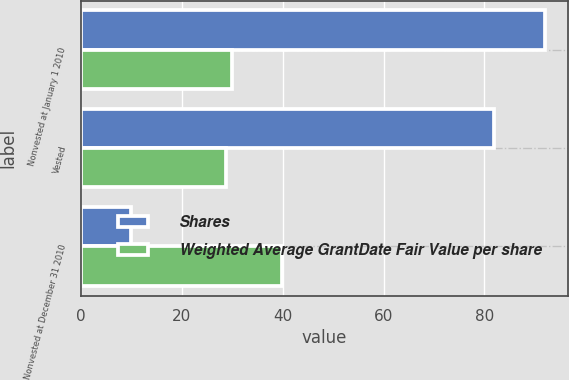Convert chart. <chart><loc_0><loc_0><loc_500><loc_500><stacked_bar_chart><ecel><fcel>Nonvested at January 1 2010<fcel>Vested<fcel>Nonvested at December 31 2010<nl><fcel>Shares<fcel>92<fcel>82<fcel>10<nl><fcel>Weighted Average GrantDate Fair Value per share<fcel>30.02<fcel>28.66<fcel>39.9<nl></chart> 